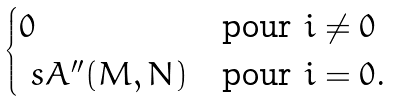<formula> <loc_0><loc_0><loc_500><loc_500>\begin{cases} 0 & \text {pour $i\ne 0$} \\ \ s A ^ { \prime \prime } ( M , N ) & \text {pour $i=0$.} \end{cases}</formula> 